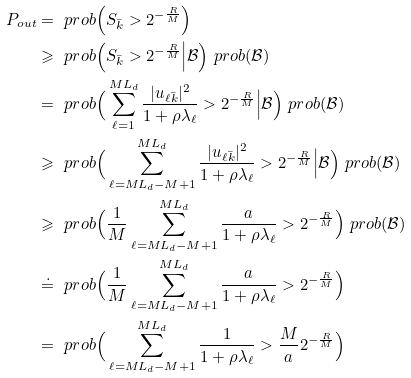Convert formula to latex. <formula><loc_0><loc_0><loc_500><loc_500>P _ { o u t } & = \ p r o b \Big ( S _ { \bar { k } } > 2 ^ { - \frac { R } { M } } \Big ) \\ & \geqslant \ p r o b \Big ( S _ { \bar { k } } > 2 ^ { - \frac { R } { M } } \Big | \mathcal { B } \Big ) \ p r o b ( \mathcal { B } ) \\ & = \ p r o b \Big ( \sum _ { \ell = 1 } ^ { M L _ { d } } \frac { | u _ { \ell \bar { k } } | ^ { 2 } } { 1 + \rho \lambda _ { \ell } } > 2 ^ { - \frac { R } { M } } \Big | \mathcal { B } \Big ) \ p r o b ( \mathcal { B } ) \\ & \geqslant \ p r o b \Big ( \sum _ { \ell = M L _ { d } - M + 1 } ^ { M L _ { d } } \frac { | u _ { \ell \bar { k } } | ^ { 2 } } { 1 + \rho \lambda _ { \ell } } > 2 ^ { - \frac { R } { M } } \Big | \mathcal { B } \Big ) \ p r o b ( \mathcal { B } ) \\ & \geqslant \ p r o b \Big ( \frac { 1 } { M } \sum _ { \ell = M L _ { d } - M + 1 } ^ { M L _ { d } } \frac { a } { 1 + \rho \lambda _ { \ell } } > 2 ^ { - \frac { R } { M } } \Big ) \ p r o b ( \mathcal { B } ) \\ & \doteq \ p r o b \Big ( \frac { 1 } { M } \sum _ { \ell = M L _ { d } - M + 1 } ^ { M L _ { d } } \frac { a } { 1 + \rho \lambda _ { \ell } } > 2 ^ { - \frac { R } { M } } \Big ) \\ & = \ p r o b \Big ( \sum _ { \ell = M L _ { d } - M + 1 } ^ { M L _ { d } } \frac { 1 } { 1 + \rho \lambda _ { \ell } } > \frac { M } { a } 2 ^ { - \frac { R } { M } } \Big )</formula> 